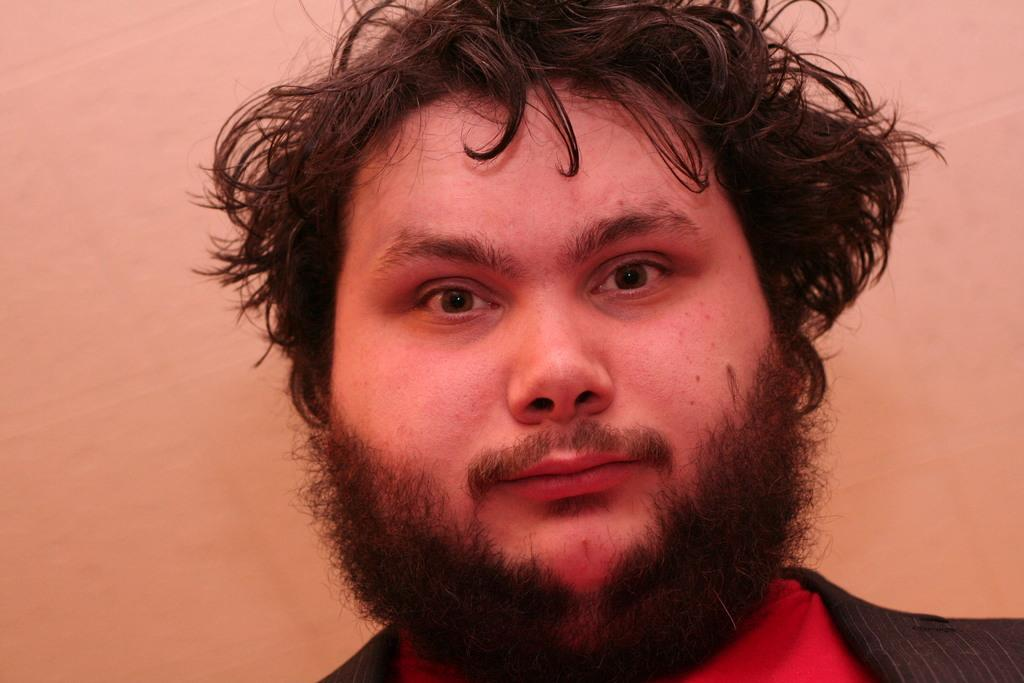What is the main subject of the image? There is a person in the image. Can you describe the person's position in the image? The person is in front. What is visible behind the person? There is a wall behind the person. How many rabbits can be seen hopping in the image? There are no rabbits present in the image. What type of sea creature is visible in the image? There is no sea creature present in the image. 